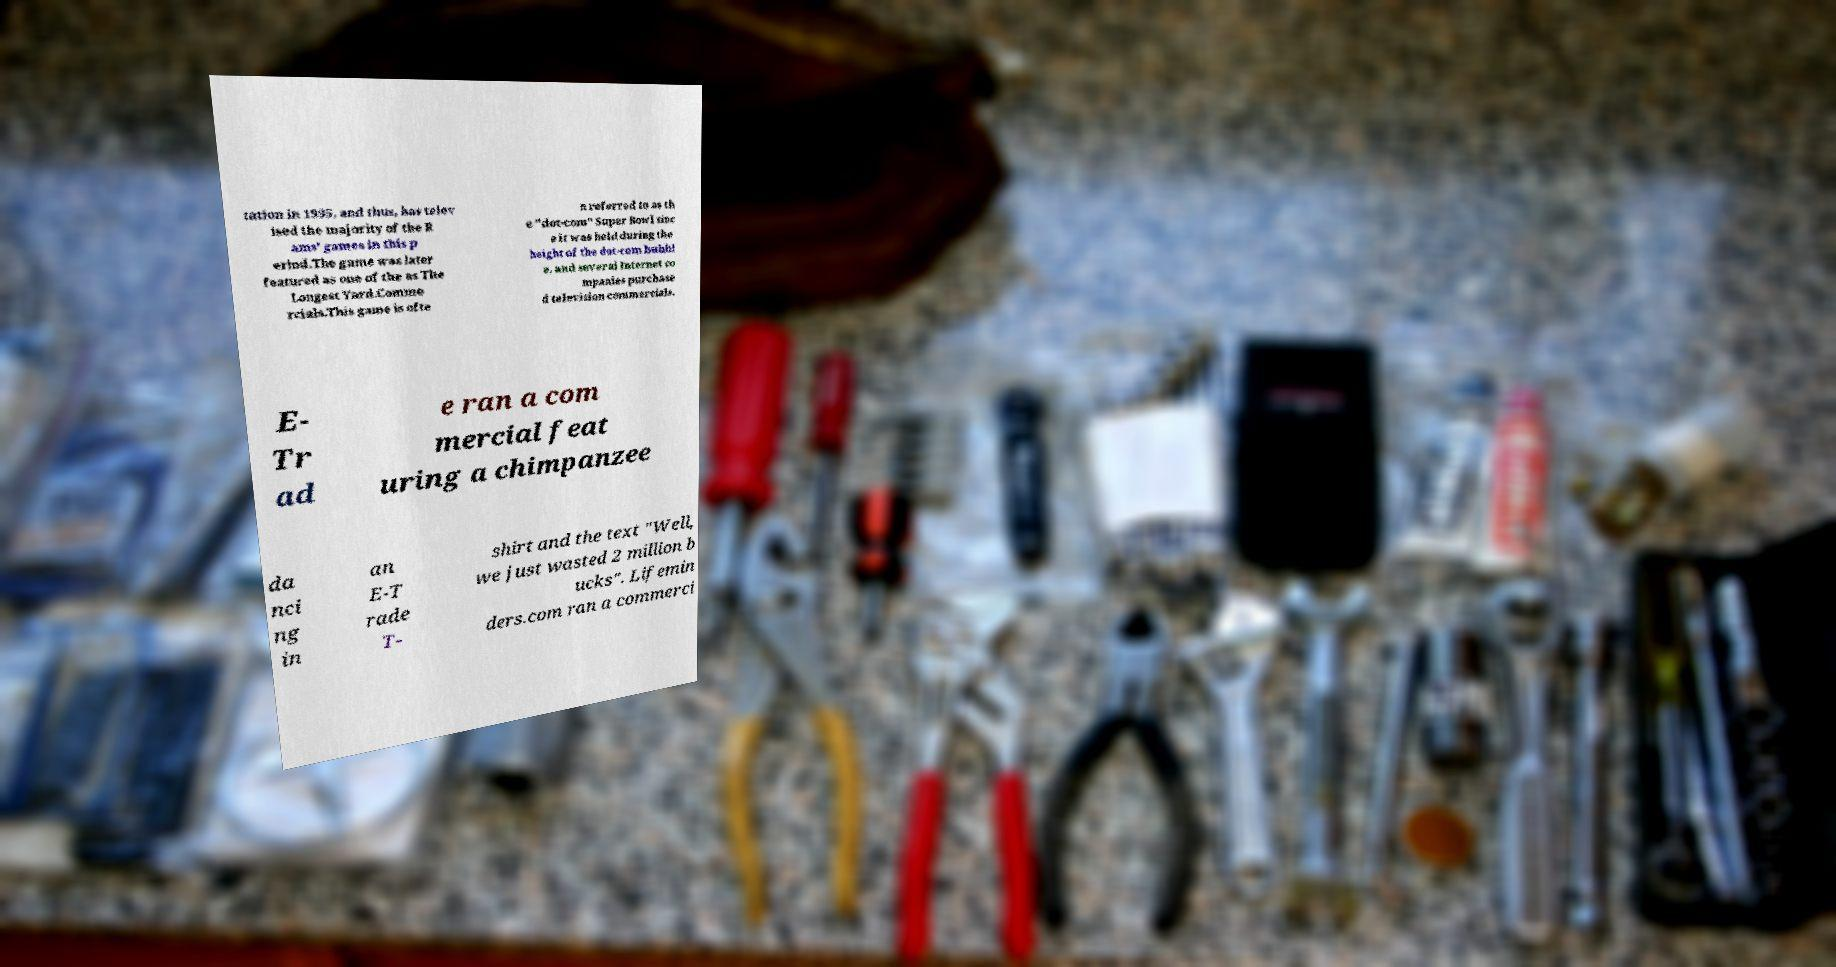Please read and relay the text visible in this image. What does it say? tation in 1995, and thus, has telev ised the majority of the R ams' games in this p eriod.The game was later featured as one of the as The Longest Yard.Comme rcials.This game is ofte n referred to as th e "dot-com" Super Bowl sinc e it was held during the height of the dot-com bubbl e, and several Internet co mpanies purchase d television commercials. E- Tr ad e ran a com mercial feat uring a chimpanzee da nci ng in an E-T rade T- shirt and the text "Well, we just wasted 2 million b ucks". Lifemin ders.com ran a commerci 